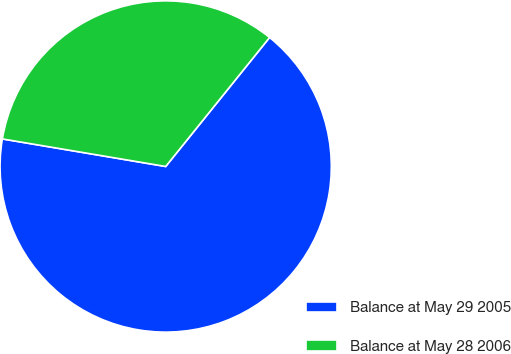Convert chart to OTSL. <chart><loc_0><loc_0><loc_500><loc_500><pie_chart><fcel>Balance at May 29 2005<fcel>Balance at May 28 2006<nl><fcel>66.87%<fcel>33.13%<nl></chart> 